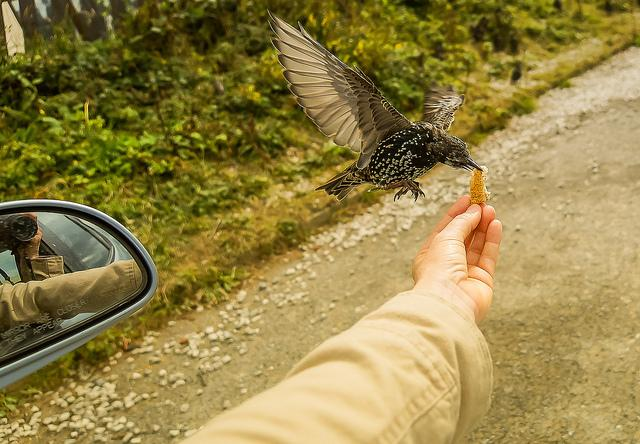What is the man doing to the bird? feeding it 